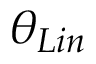<formula> <loc_0><loc_0><loc_500><loc_500>\theta _ { L i n }</formula> 